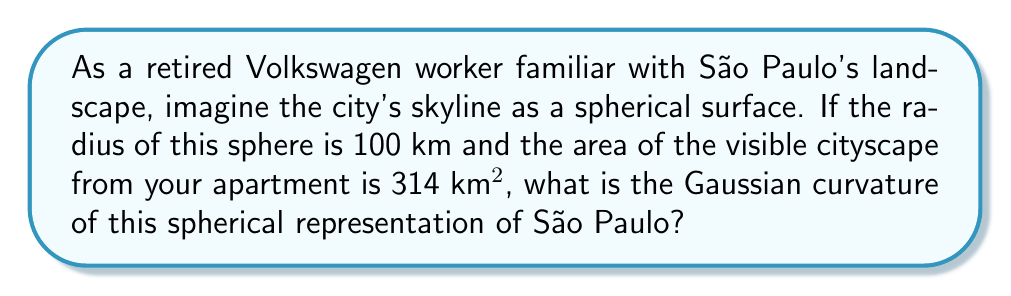Can you solve this math problem? Let's approach this step-by-step:

1) First, recall that for a sphere, the Gaussian curvature $K$ is constant and given by:

   $$K = \frac{1}{R^2}$$

   where $R$ is the radius of the sphere.

2) We're given that the radius $R = 100$ km.

3) To verify our understanding, let's calculate the area of the visible cityscape:
   
   The area of a spherical cap is given by $A = 2\pi Rh$, where $h$ is the height of the cap.
   
   We're given $A = 314$ km².
   
   $$314 = 2\pi \cdot 100 \cdot h$$
   $$h = \frac{314}{200\pi} \approx 0.5 \text{ km}$$

   This small height compared to the radius confirms that we're dealing with a relatively small portion of the sphere, which aligns with viewing a cityscape.

4) Now, let's calculate the Gaussian curvature:

   $$K = \frac{1}{R^2} = \frac{1}{(100)^2} = \frac{1}{10000} = 0.0001 \text{ km}^{-2}$$

5) Convert to m^-2 for a more practical unit:
   
   $$K = 0.0001 \text{ km}^{-2} = 1 \times 10^{-10} \text{ m}^{-2}$$

This extremely small curvature reflects the fact that from a human perspective, the Earth (and by extension, the cityscape of Sao Paulo) appears nearly flat, despite being modeled as a sphere in this problem.
Answer: $1 \times 10^{-10} \text{ m}^{-2}$ 